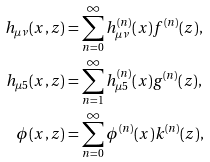<formula> <loc_0><loc_0><loc_500><loc_500>h _ { \mu \nu } ( x , z ) & = \sum _ { n = 0 } ^ { \infty } h ^ { ( n ) } _ { \mu \nu } ( x ) f ^ { ( n ) } ( z ) , \\ h _ { \mu 5 } ( x , z ) & = \sum _ { n = 1 } ^ { \infty } h ^ { ( n ) } _ { \mu 5 } ( x ) g ^ { ( n ) } ( z ) , \\ \phi ( x , z ) & = \sum _ { n = 0 } ^ { \infty } \phi ^ { ( n ) } ( x ) k ^ { ( n ) } ( z ) ,</formula> 